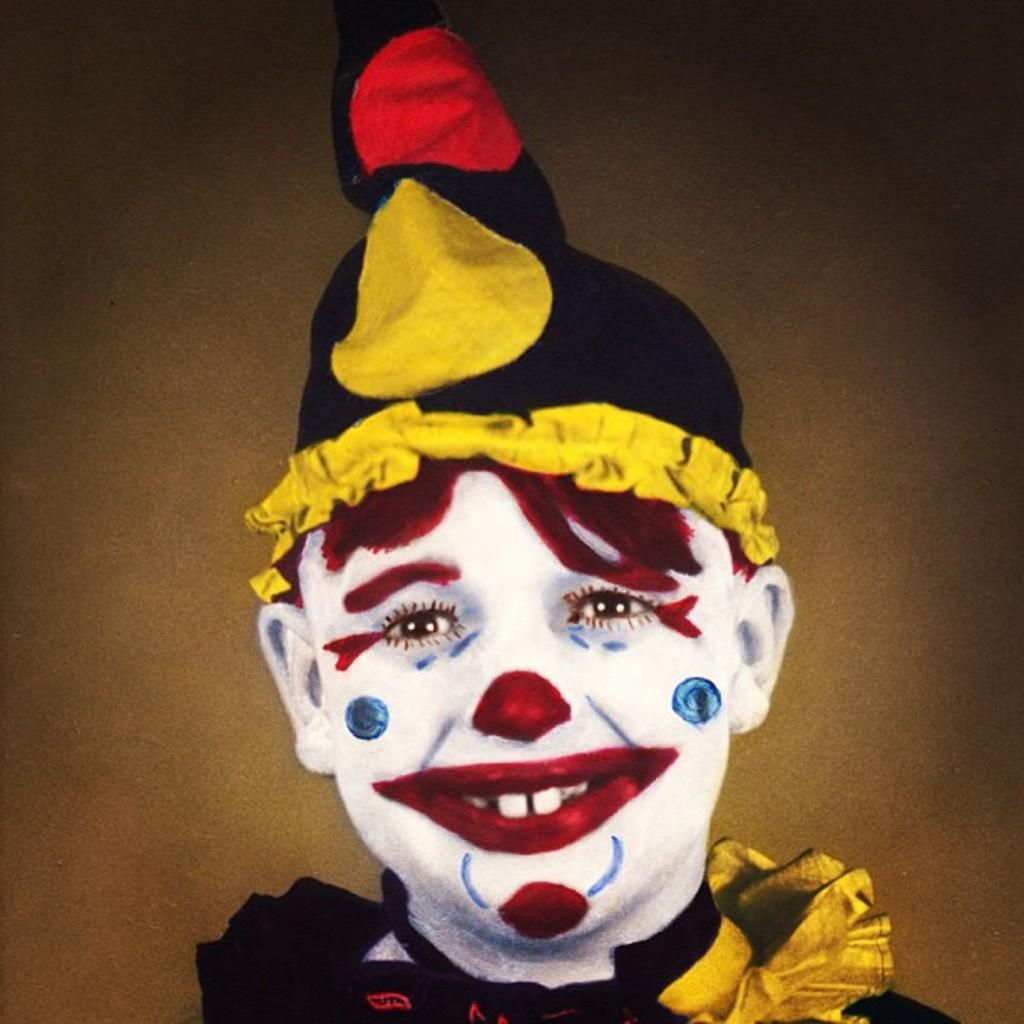What is the main subject of the image? There is a person in the image. What can be observed on the person's face? The person has painting on their face. What type of headwear is the person wearing? The person is wearing a cap on their head. What is the person's facial expression? The person is smiling. What type of power source is the person using to create the painting on their face? There is no indication in the image that the person is using a power source to create the painting on their face. How does the person's health appear in the image? The person's health cannot be determined from the image, as it only shows their face with painting and their cap. 